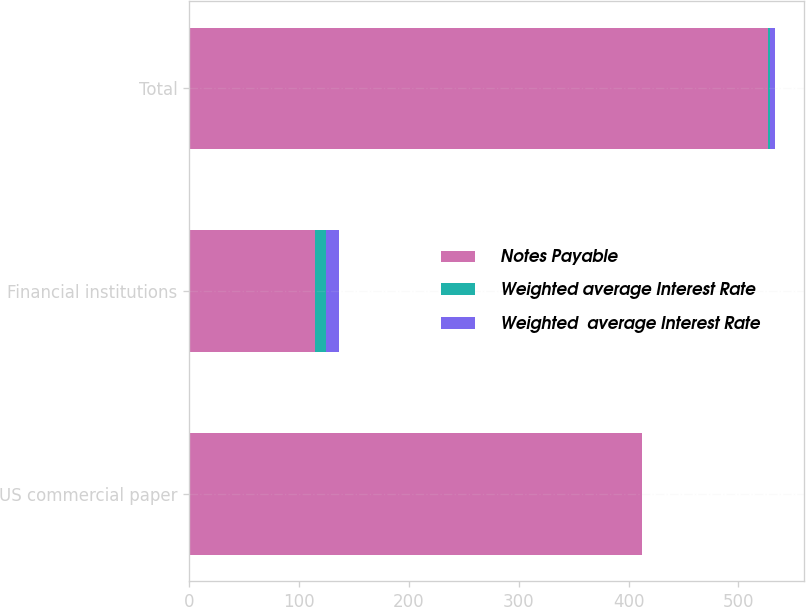Convert chart to OTSL. <chart><loc_0><loc_0><loc_500><loc_500><stacked_bar_chart><ecel><fcel>US commercial paper<fcel>Financial institutions<fcel>Total<nl><fcel>Notes Payable<fcel>412<fcel>114.5<fcel>526.5<nl><fcel>Weighted average Interest Rate<fcel>0.2<fcel>10<fcel>2.4<nl><fcel>Weighted  average Interest Rate<fcel>0.2<fcel>11.5<fcel>4.5<nl></chart> 